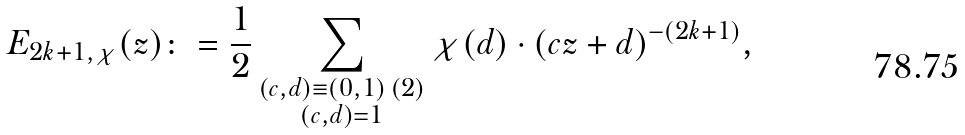<formula> <loc_0><loc_0><loc_500><loc_500>E _ { 2 k + 1 , \chi } ( z ) \colon = \frac { 1 } { 2 } \sum _ { \substack { ( c , d ) \equiv ( 0 , 1 ) \, ( 2 ) \\ ( c , d ) = 1 } } \chi ( d ) \cdot { ( c z + d ) ^ { - ( 2 k + 1 ) } } ,</formula> 